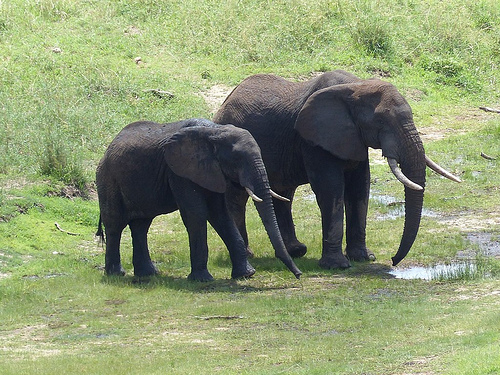Are there elephants in the green grass? Yes, there are elephants standing in the green grass in this picture. 